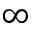<formula> <loc_0><loc_0><loc_500><loc_500>\infty</formula> 